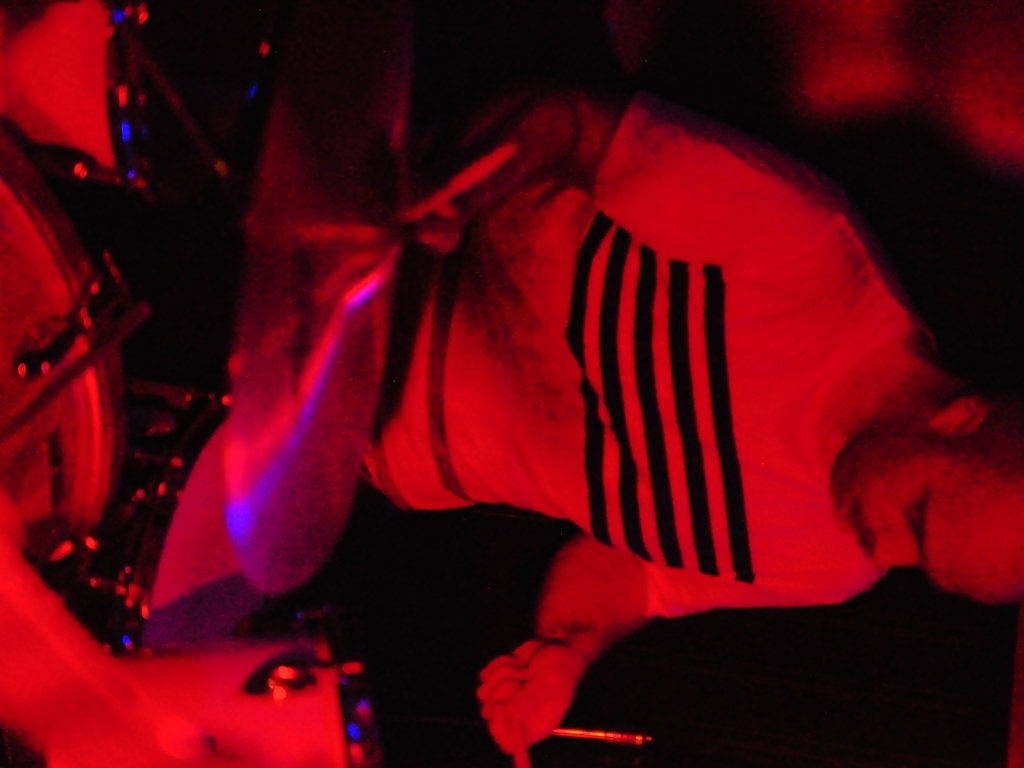Does this image suggest anything about the atmosphere of the location? The low lighting and rich, red tones create an intimate and vibrant atmosphere, which often accompanies music venues or nightlife settings, underscoring the energy and movement inherent in live performances. 